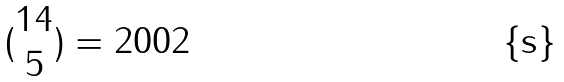Convert formula to latex. <formula><loc_0><loc_0><loc_500><loc_500>( \begin{matrix} 1 4 \\ 5 \end{matrix} ) = 2 0 0 2</formula> 